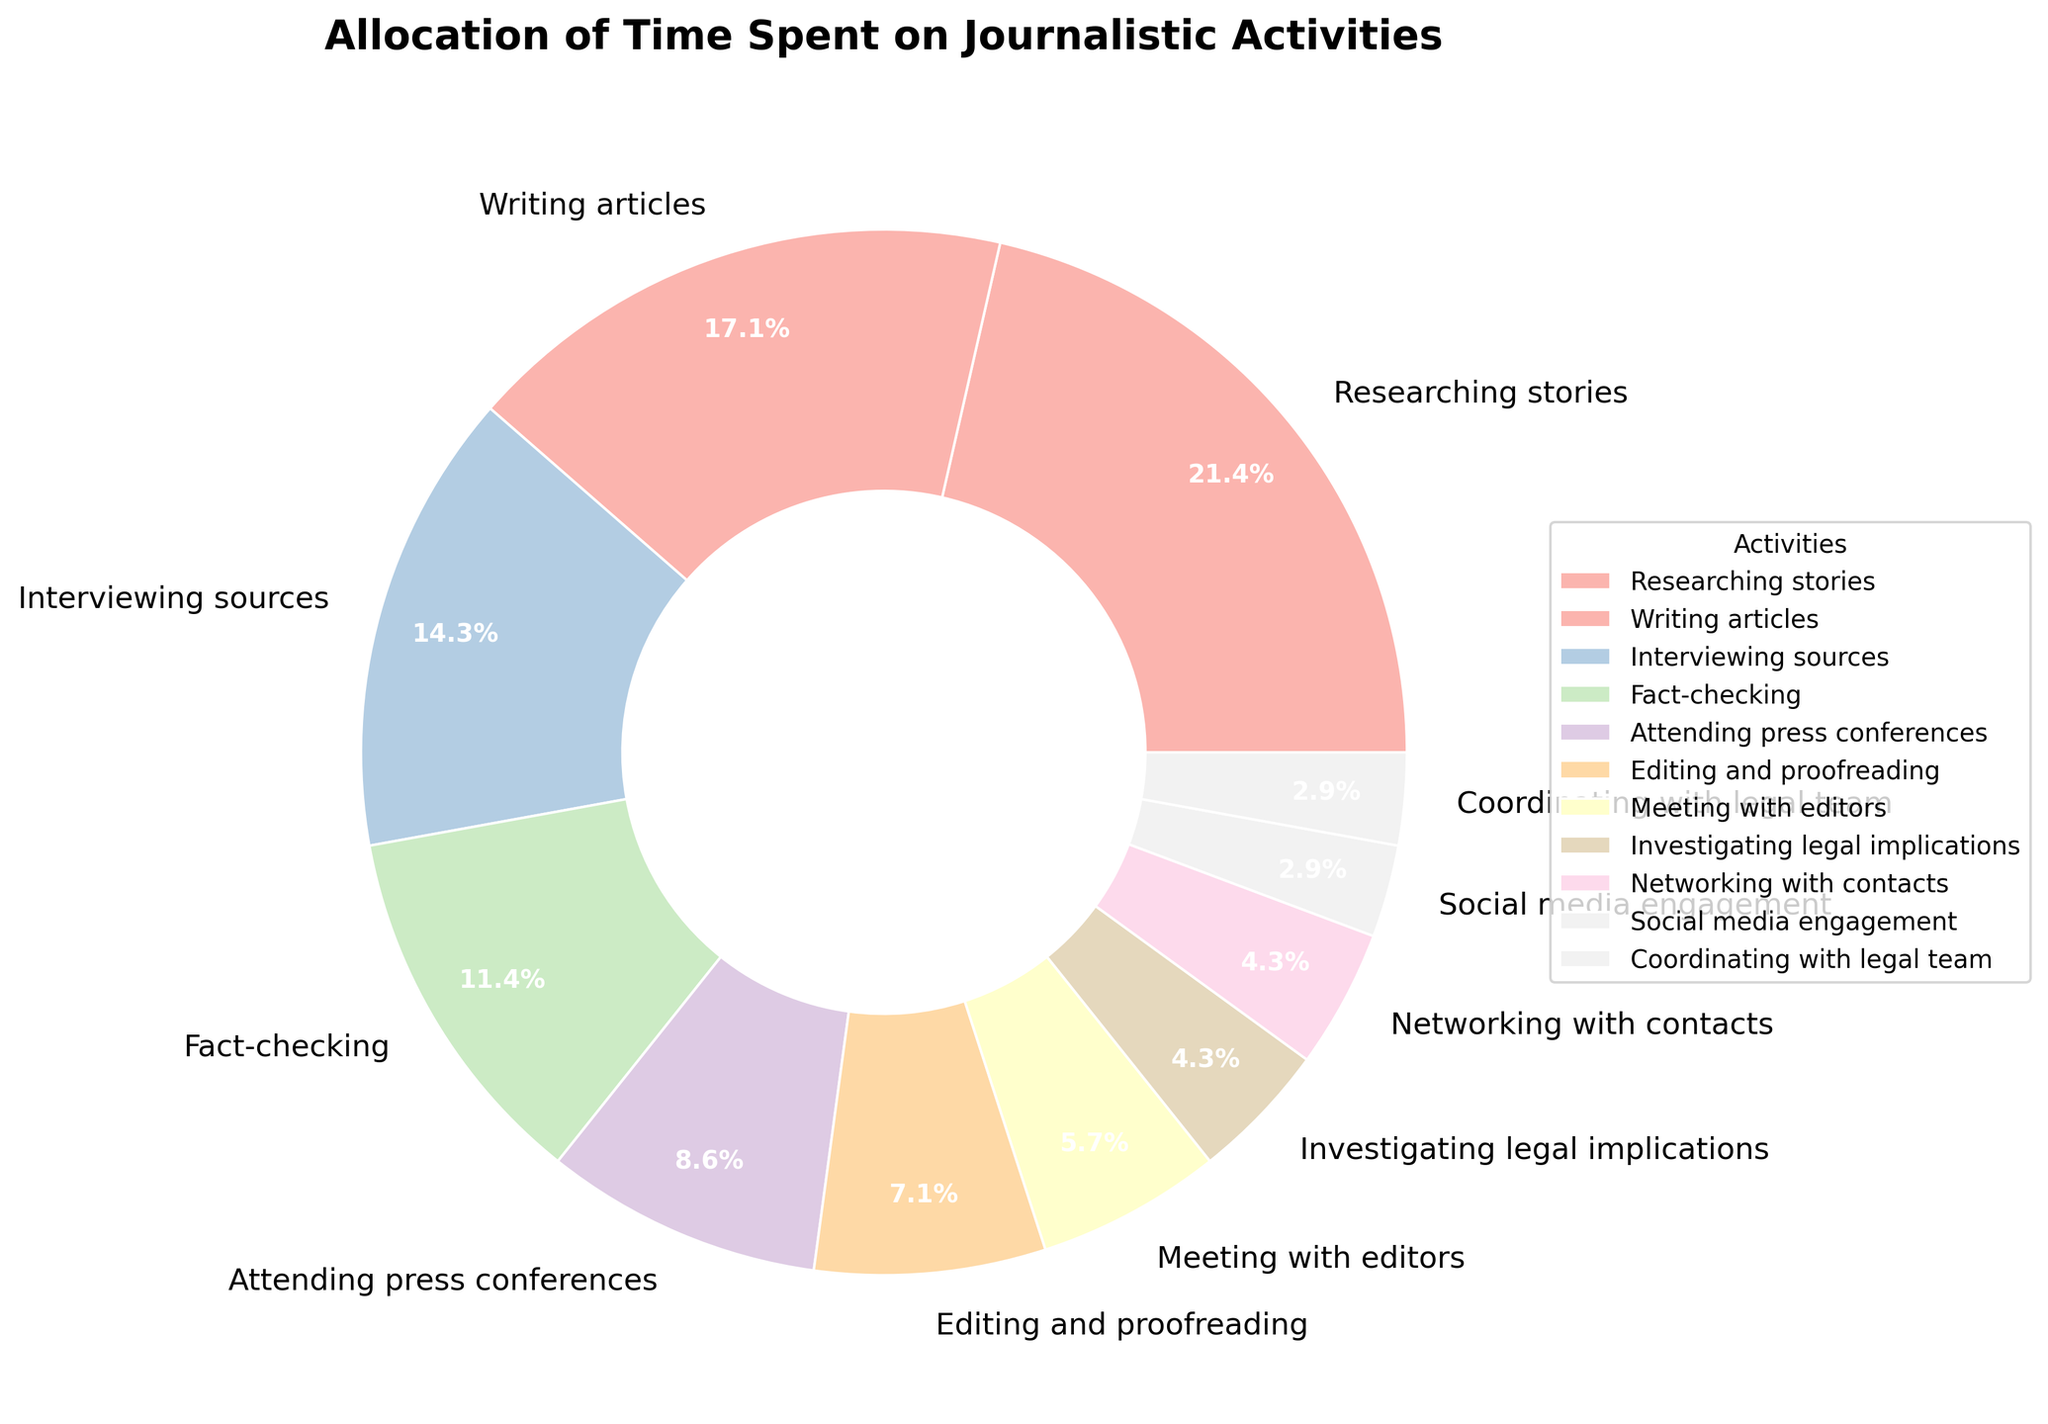What's the total percentage of time spent on activities related directly to writing and producing articles (Researching stories, Writing articles, Editing and proofreading)? The time spent on each of these activities is 15 hours for Researching stories, 12 hours for Writing articles, and 5 hours for Editing and proofreading. Adding them together gives 15 + 12 + 5 = 32 hours. The total number of hours recorded in the pie chart is 70 hours. Therefore, the percentage is (32/70) * 100 = 45.7%
Answer: 45.7% Which activity occupies the largest portion of the pie chart? By observing the pie chart, the largest wedge is labeled "Researching stories".
Answer: Researching stories Is more time spent on attending press conferences or on investigating legal implications? The hours spent on attending press conferences is 6, while the hours spent on investigating legal implications is 3. Since 6 is greater than 3, more time is spent on attending press conferences.
Answer: Attending press conferences How much more time is spent on fact-checking compared to social media engagement? Fact-checking takes 8 hours and social media engagement takes 2 hours. The difference in time is 8 - 2 = 6 hours.
Answer: 6 hours What is the combined percentage of time spent on networking with contacts and coordinating with the legal team? The time spent on networking with contacts is 3 hours and on coordinating with the legal team is 2 hours. Adding these gives 3 + 2 = 5 hours. The total number of hours is 70. Therefore, the combined percentage is (5/70) * 100 = 7.1%.
Answer: 7.1% Is more than 20% of the total time spent on writing articles and interviewing sources together? The time spent on writing articles is 12 hours, and on interviewing sources is 10 hours. Added together, this is 12 + 10 = 22 hours. The total number of hours is 70. Therefore, the percentage is (22/70) * 100 = 31.4%, which is more than 20%.
Answer: Yes What is the difference in percentage between the time spent on meeting with editors and researching stories? Time spent on meeting with editors is 4 hours and researching stories is 15 hours. The total hours are 70. The percentages are (4/70) * 100 = 5.7% for meeting with editors and (15/70) * 100 = 21.4% for researching stories. The difference is 21.4% - 5.7% = 15.7%.
Answer: 15.7% What fraction of the work week is spent on investigating legal implications, writing articles, and coordinating with the legal team? The hours spent are: investigating legal implications = 3, writing articles = 12, and coordinating with legal team = 2. Sum these to get 3 + 12 + 2 = 17 hours. The total number of hours is 70. The fraction is 17/70.
Answer: 17/70 